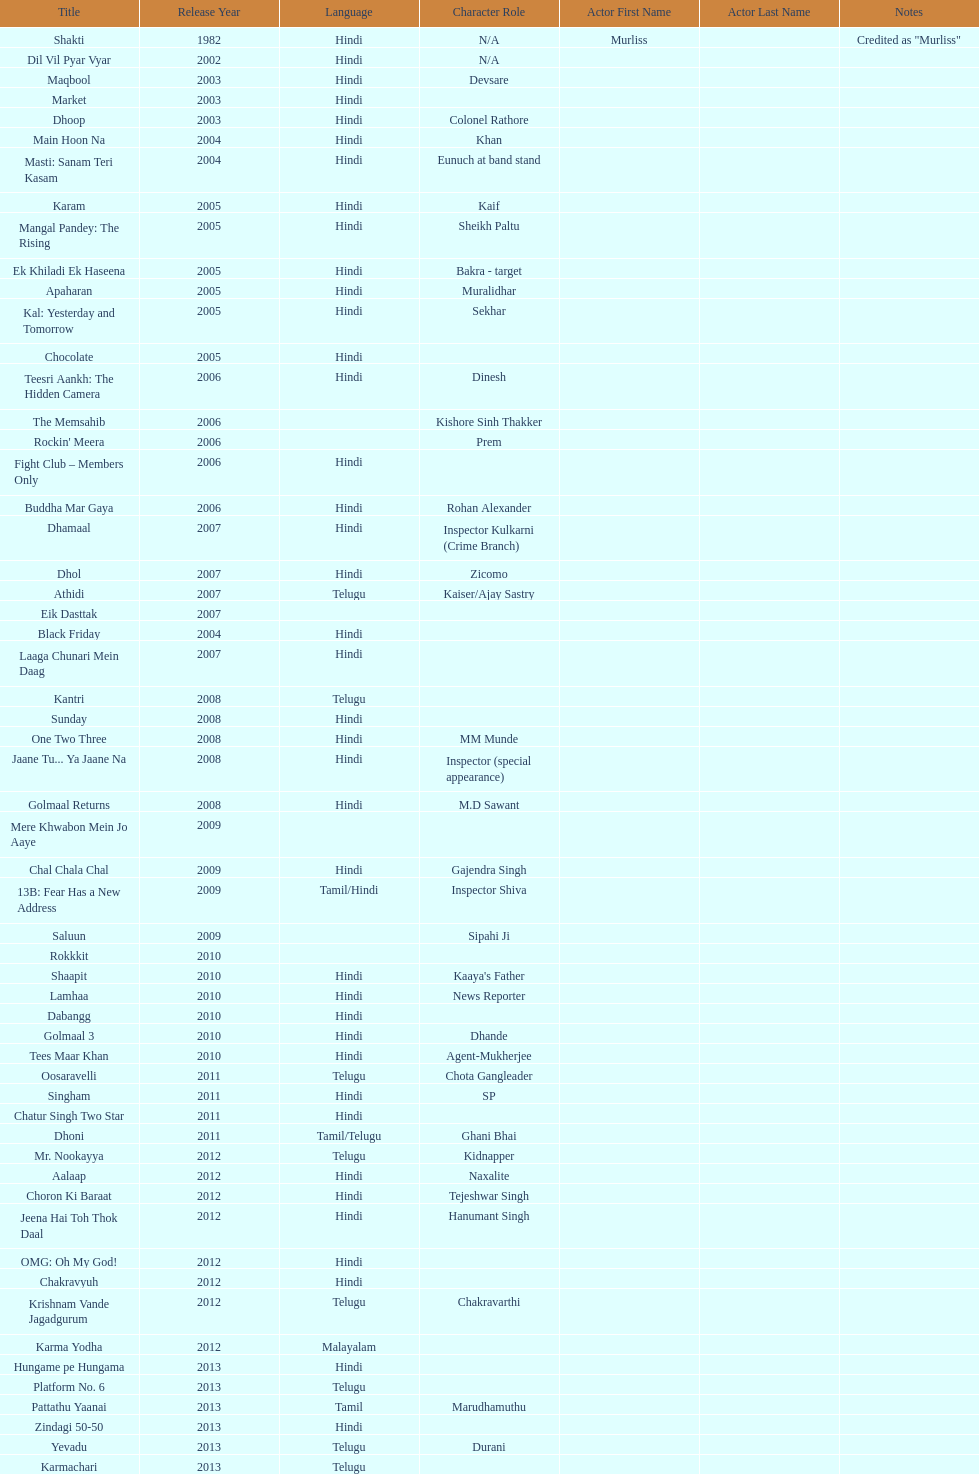What title is before dhol in 2007? Dhamaal. 